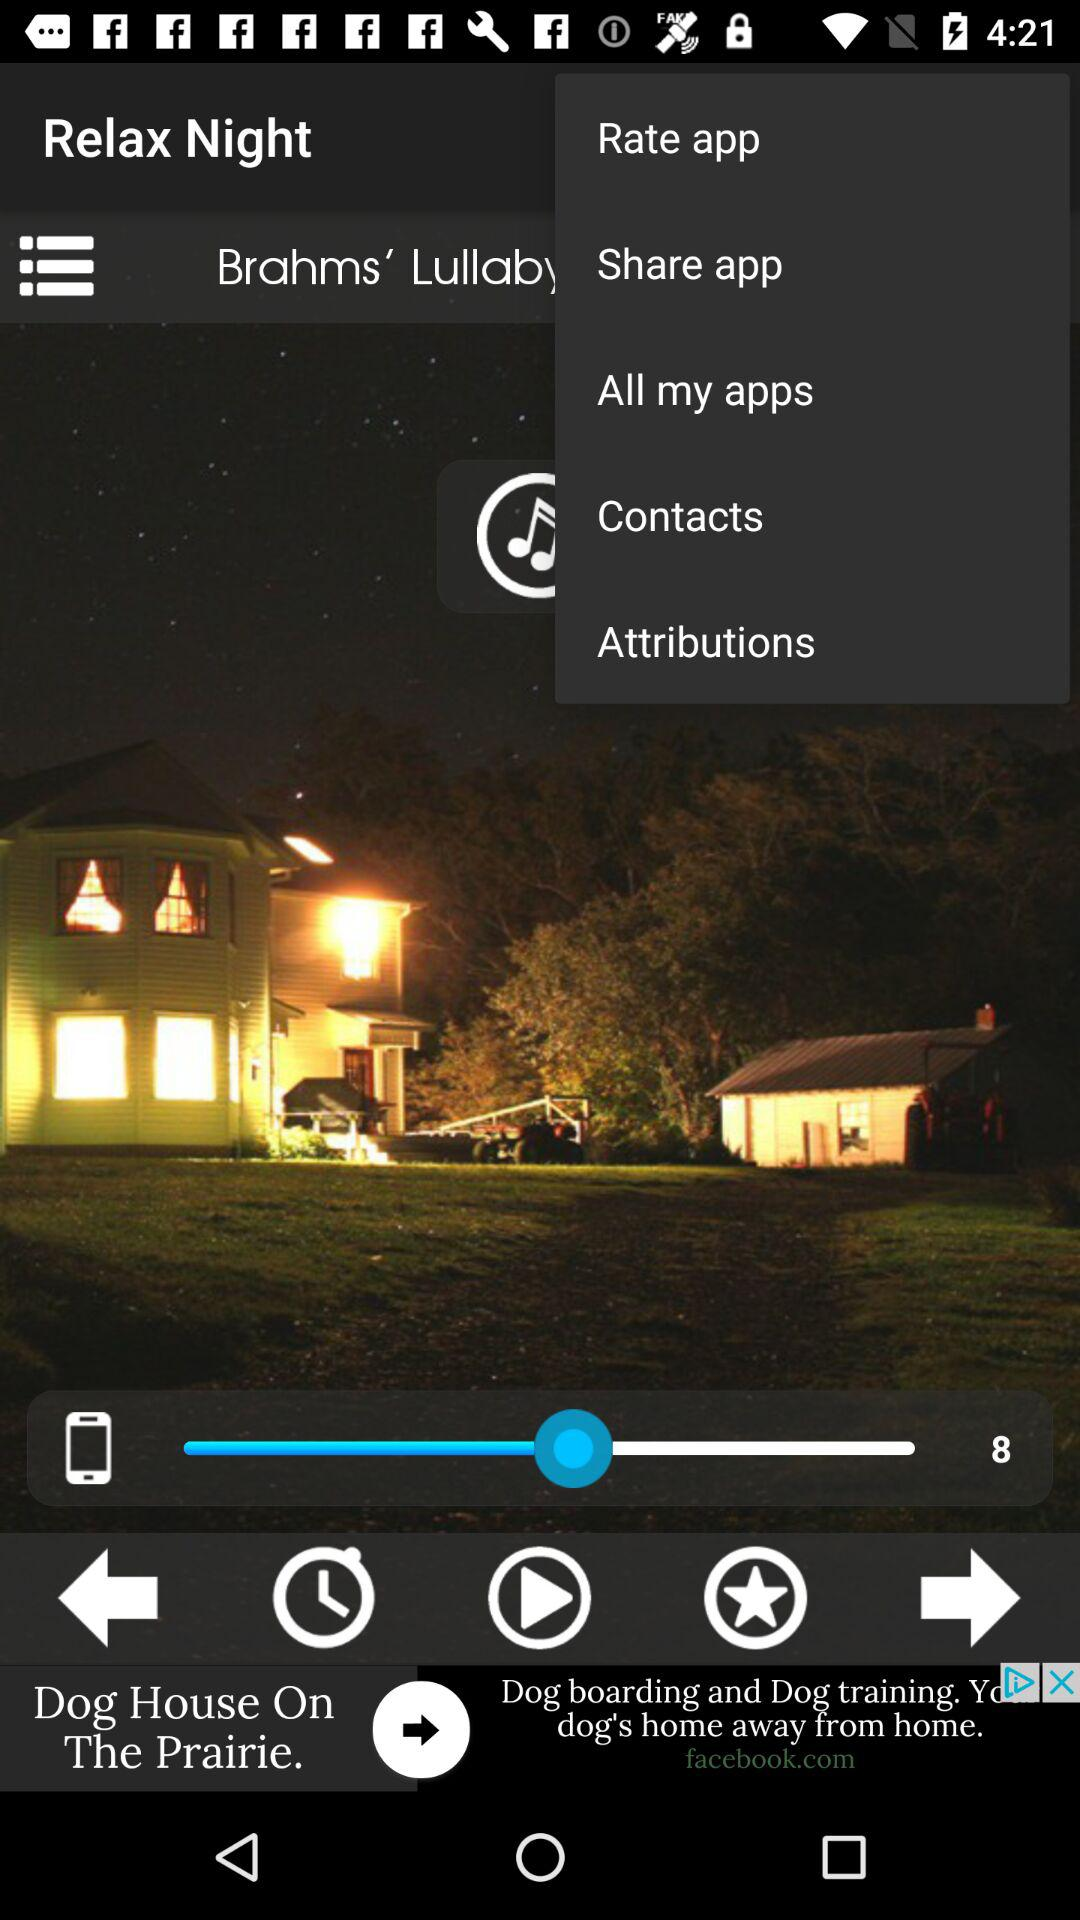What is the name of the last audio that was played? The name of the last audio that was played is "Brahms' Lullaby". 